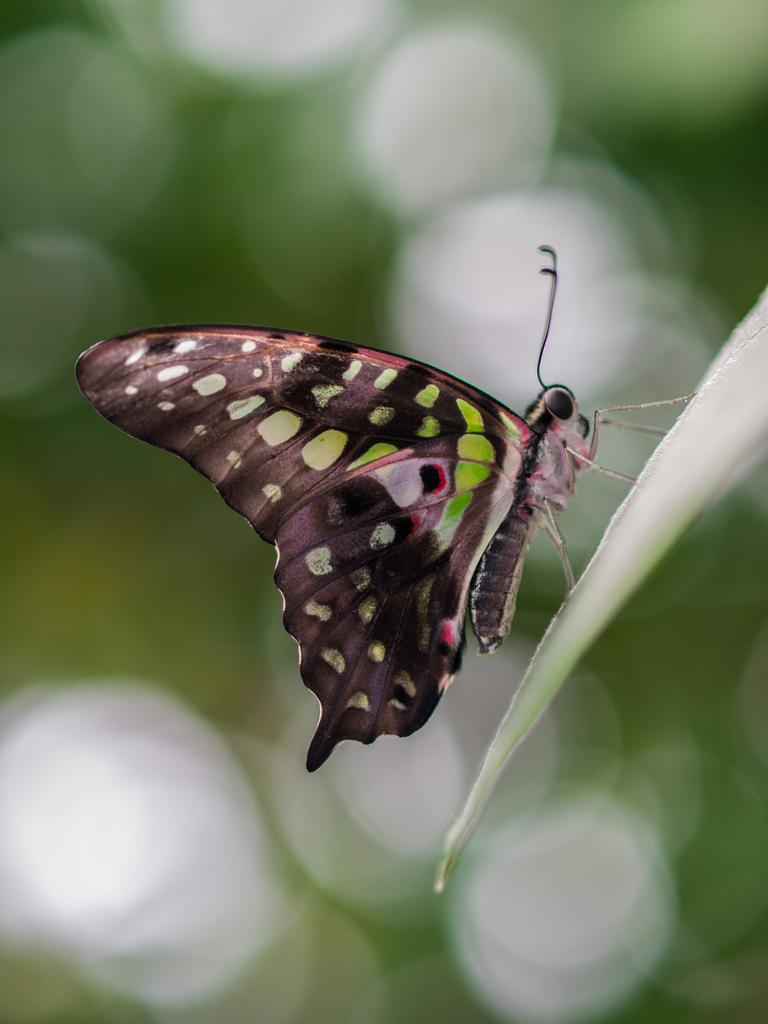What is the main subject of the image? There is a butterfly in the image. Where is the butterfly located? The butterfly is on a leaf. Can you describe the background of the image? The background of the image is blurred. What type of machine can be seen in the image? There is no machine present in the image; it features a butterfly on a leaf with a blurred background. What creature is interacting with the butterfly in the image? There is no other creature interacting with the butterfly in the image; it is simply on a leaf. 